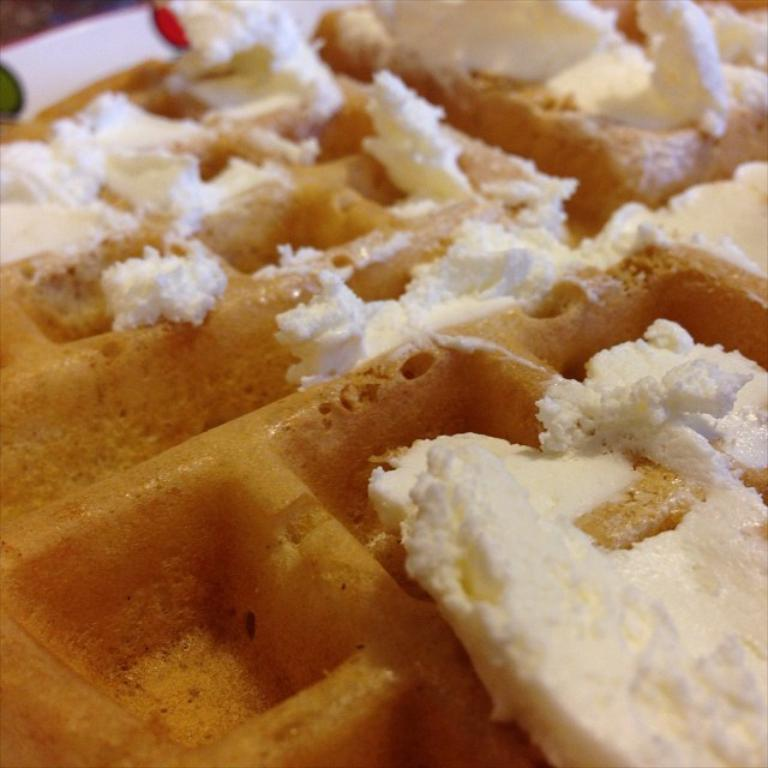What types of items can be seen in the image? There are food items in the image. Can you describe the background of the image? There are objects visible in the background of the image. What type of cream is being used to attack the food items in the image? There is no cream or attack present in the image; it only features food items and objects in the background. 